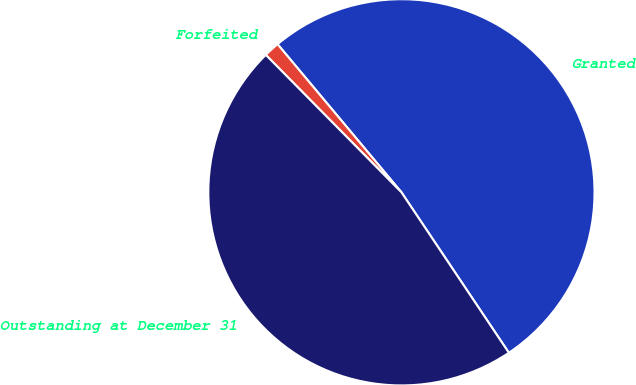Convert chart. <chart><loc_0><loc_0><loc_500><loc_500><pie_chart><fcel>Granted<fcel>Forfeited<fcel>Outstanding at December 31<nl><fcel>51.7%<fcel>1.31%<fcel>47.0%<nl></chart> 